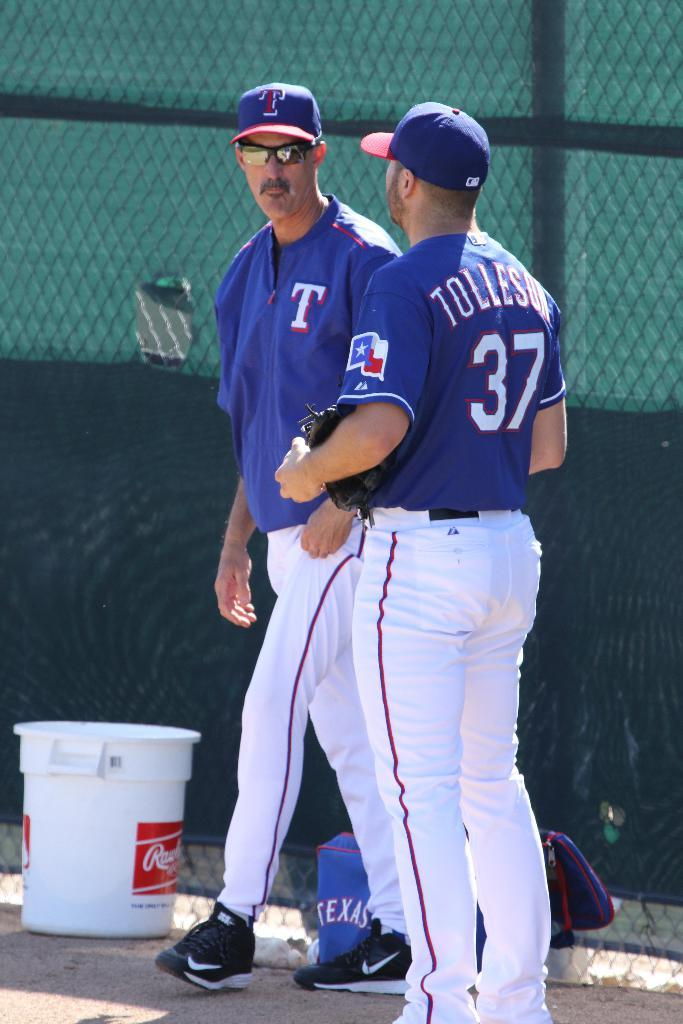<image>
Render a clear and concise summary of the photo. A Tolleson baseball player wearing number 37 on his jersey, is standing to the side of the field, talking to another member of the team. 